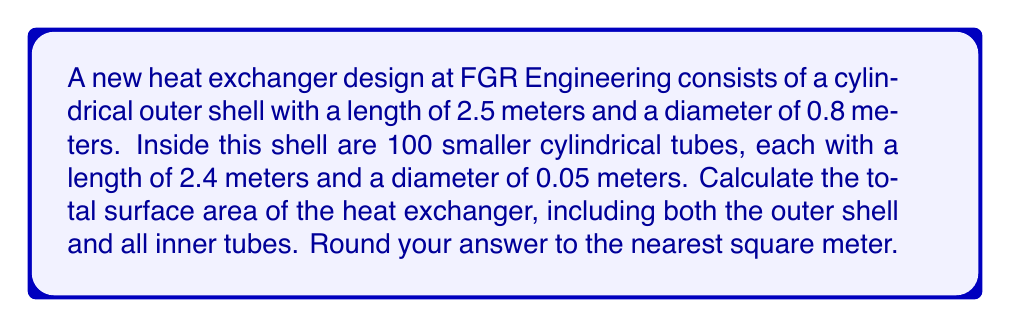Help me with this question. To solve this problem, we need to calculate the surface areas of the outer shell and the inner tubes separately, then sum them up.

1. Surface area of the outer shell:
   The outer shell is a cylinder. Its surface area consists of the lateral area and two circular ends.
   
   Lateral area: $A_l = \pi d h$
   where $d$ is the diameter and $h$ is the height (length) of the cylinder.
   
   $A_l = \pi \cdot 0.8 \cdot 2.5 = 6.28$ m²
   
   Area of circular ends: $A_e = 2 \cdot \pi r^2 = 2 \cdot \pi \cdot (0.4)^2 = 1.01$ m²
   
   Total surface area of outer shell: $A_s = A_l + A_e = 6.28 + 1.01 = 7.29$ m²

2. Surface area of inner tubes:
   Each inner tube is also a cylinder. We need to calculate the surface area of one tube and multiply by 100.
   
   Lateral area of one tube: $A_{tl} = \pi d h = \pi \cdot 0.05 \cdot 2.4 = 0.377$ m²
   
   Area of circular ends of one tube: $A_{te} = 2 \cdot \pi r^2 = 2 \cdot \pi \cdot (0.025)^2 = 0.00393$ m²
   
   Total surface area of one tube: $A_t = A_{tl} + A_{te} = 0.377 + 0.00393 = 0.38093$ m²
   
   Surface area of all 100 tubes: $A_{all} = 100 \cdot A_t = 100 \cdot 0.38093 = 38.093$ m²

3. Total surface area of the heat exchanger:
   $A_{total} = A_s + A_{all} = 7.29 + 38.093 = 45.383$ m²

Rounding to the nearest square meter: 45 m²
Answer: $$45 \text{ m}^2$$ 